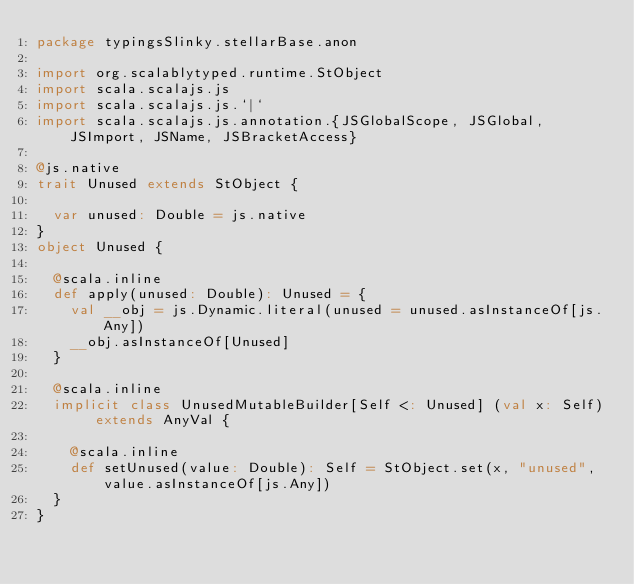<code> <loc_0><loc_0><loc_500><loc_500><_Scala_>package typingsSlinky.stellarBase.anon

import org.scalablytyped.runtime.StObject
import scala.scalajs.js
import scala.scalajs.js.`|`
import scala.scalajs.js.annotation.{JSGlobalScope, JSGlobal, JSImport, JSName, JSBracketAccess}

@js.native
trait Unused extends StObject {
  
  var unused: Double = js.native
}
object Unused {
  
  @scala.inline
  def apply(unused: Double): Unused = {
    val __obj = js.Dynamic.literal(unused = unused.asInstanceOf[js.Any])
    __obj.asInstanceOf[Unused]
  }
  
  @scala.inline
  implicit class UnusedMutableBuilder[Self <: Unused] (val x: Self) extends AnyVal {
    
    @scala.inline
    def setUnused(value: Double): Self = StObject.set(x, "unused", value.asInstanceOf[js.Any])
  }
}
</code> 